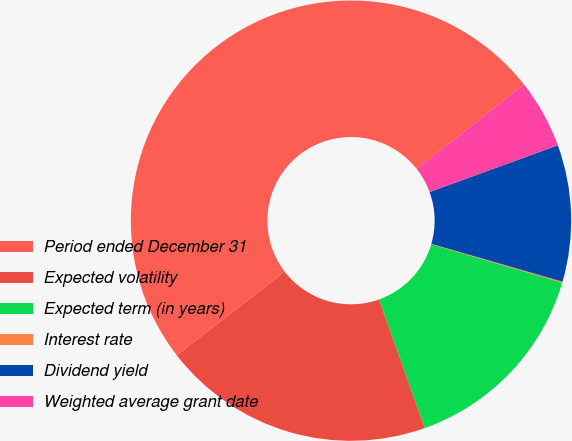Convert chart. <chart><loc_0><loc_0><loc_500><loc_500><pie_chart><fcel>Period ended December 31<fcel>Expected volatility<fcel>Expected term (in years)<fcel>Interest rate<fcel>Dividend yield<fcel>Weighted average grant date<nl><fcel>49.85%<fcel>19.98%<fcel>15.01%<fcel>0.08%<fcel>10.03%<fcel>5.05%<nl></chart> 